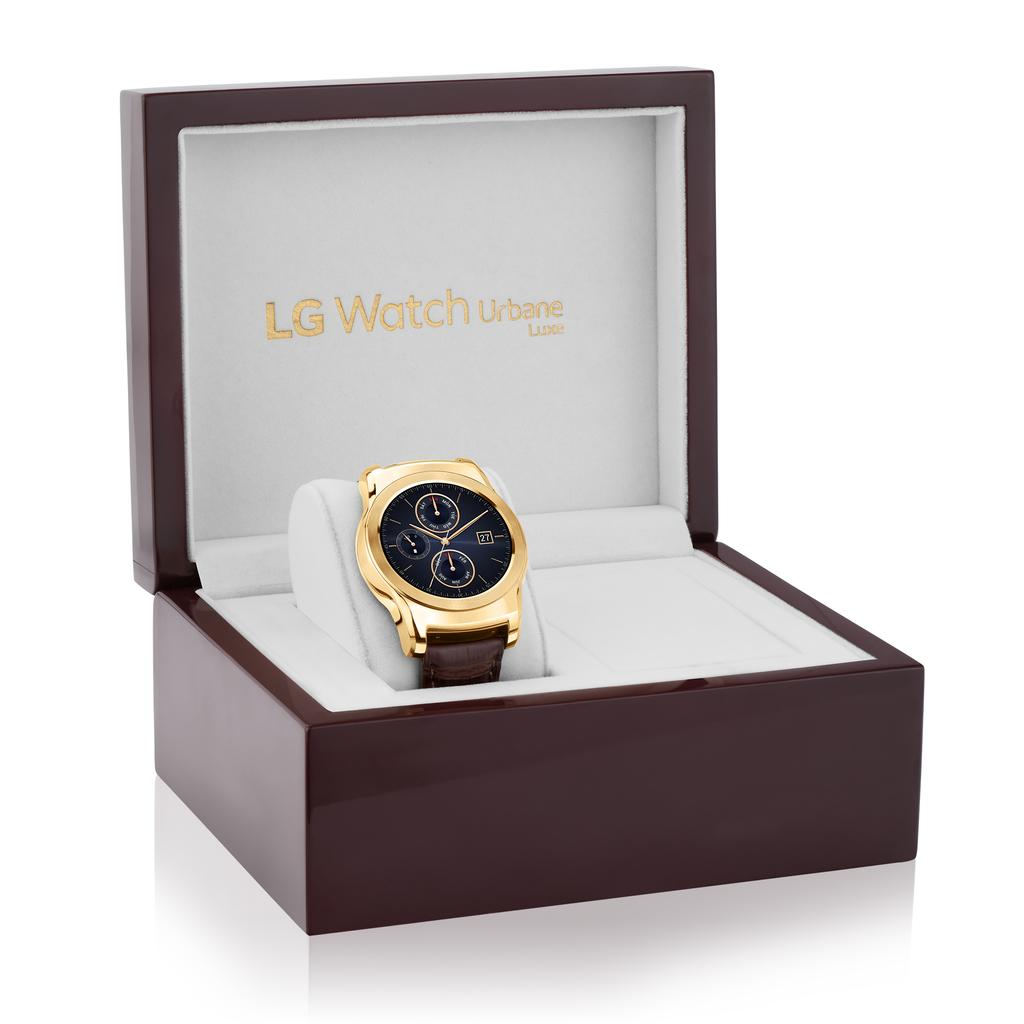<image>
Summarize the visual content of the image. Wristwatch inside of a box that says LG Watch in gold letters. 